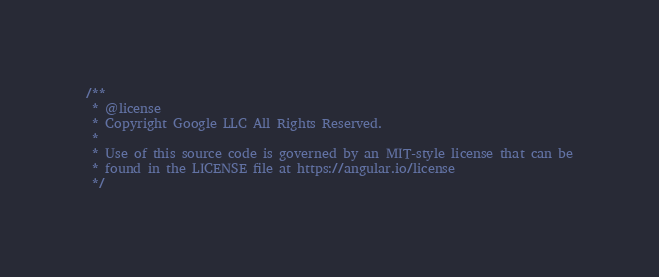Convert code to text. <code><loc_0><loc_0><loc_500><loc_500><_JavaScript_>/**
 * @license
 * Copyright Google LLC All Rights Reserved.
 *
 * Use of this source code is governed by an MIT-style license that can be
 * found in the LICENSE file at https://angular.io/license
 */</code> 